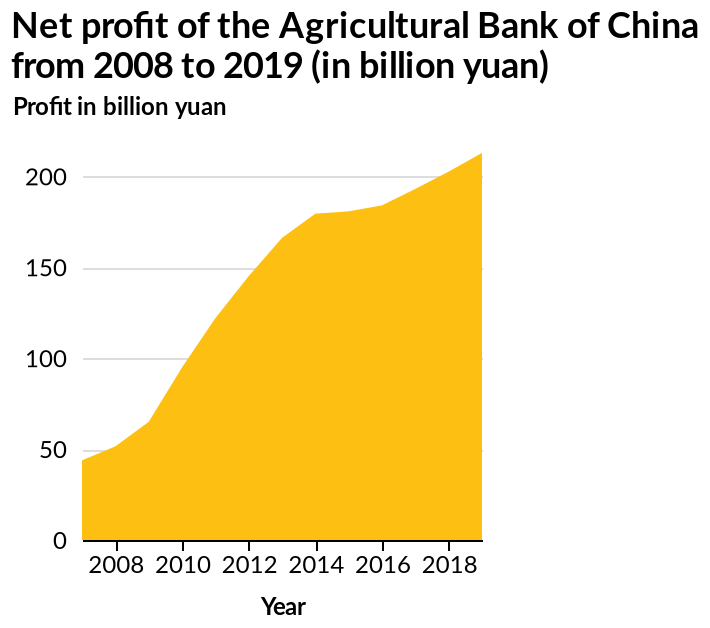<image>
Did the net profit decrease at any point between 2010 and 2014? No, the net profit had a particularly sharp rise between 2010 and 2014. Offer a thorough analysis of the image. The net profit has continued to increase each year, with a particularly sharp rise between 2010 and 2014. please describe the details of the chart Here a is a area chart titled Net profit of the Agricultural Bank of China from 2008 to 2019 (in billion yuan). The x-axis measures Year while the y-axis shows Profit in billion yuan. 